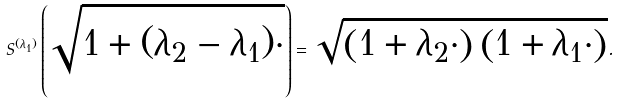Convert formula to latex. <formula><loc_0><loc_0><loc_500><loc_500>S ^ { ( \lambda _ { 1 } ) } \left ( \sqrt { 1 + ( \lambda _ { 2 } - \lambda _ { 1 } ) \cdot } \right ) = \sqrt { \left ( 1 + \lambda _ { 2 } \cdot \right ) \left ( 1 + \lambda _ { 1 } \cdot \right ) } .</formula> 